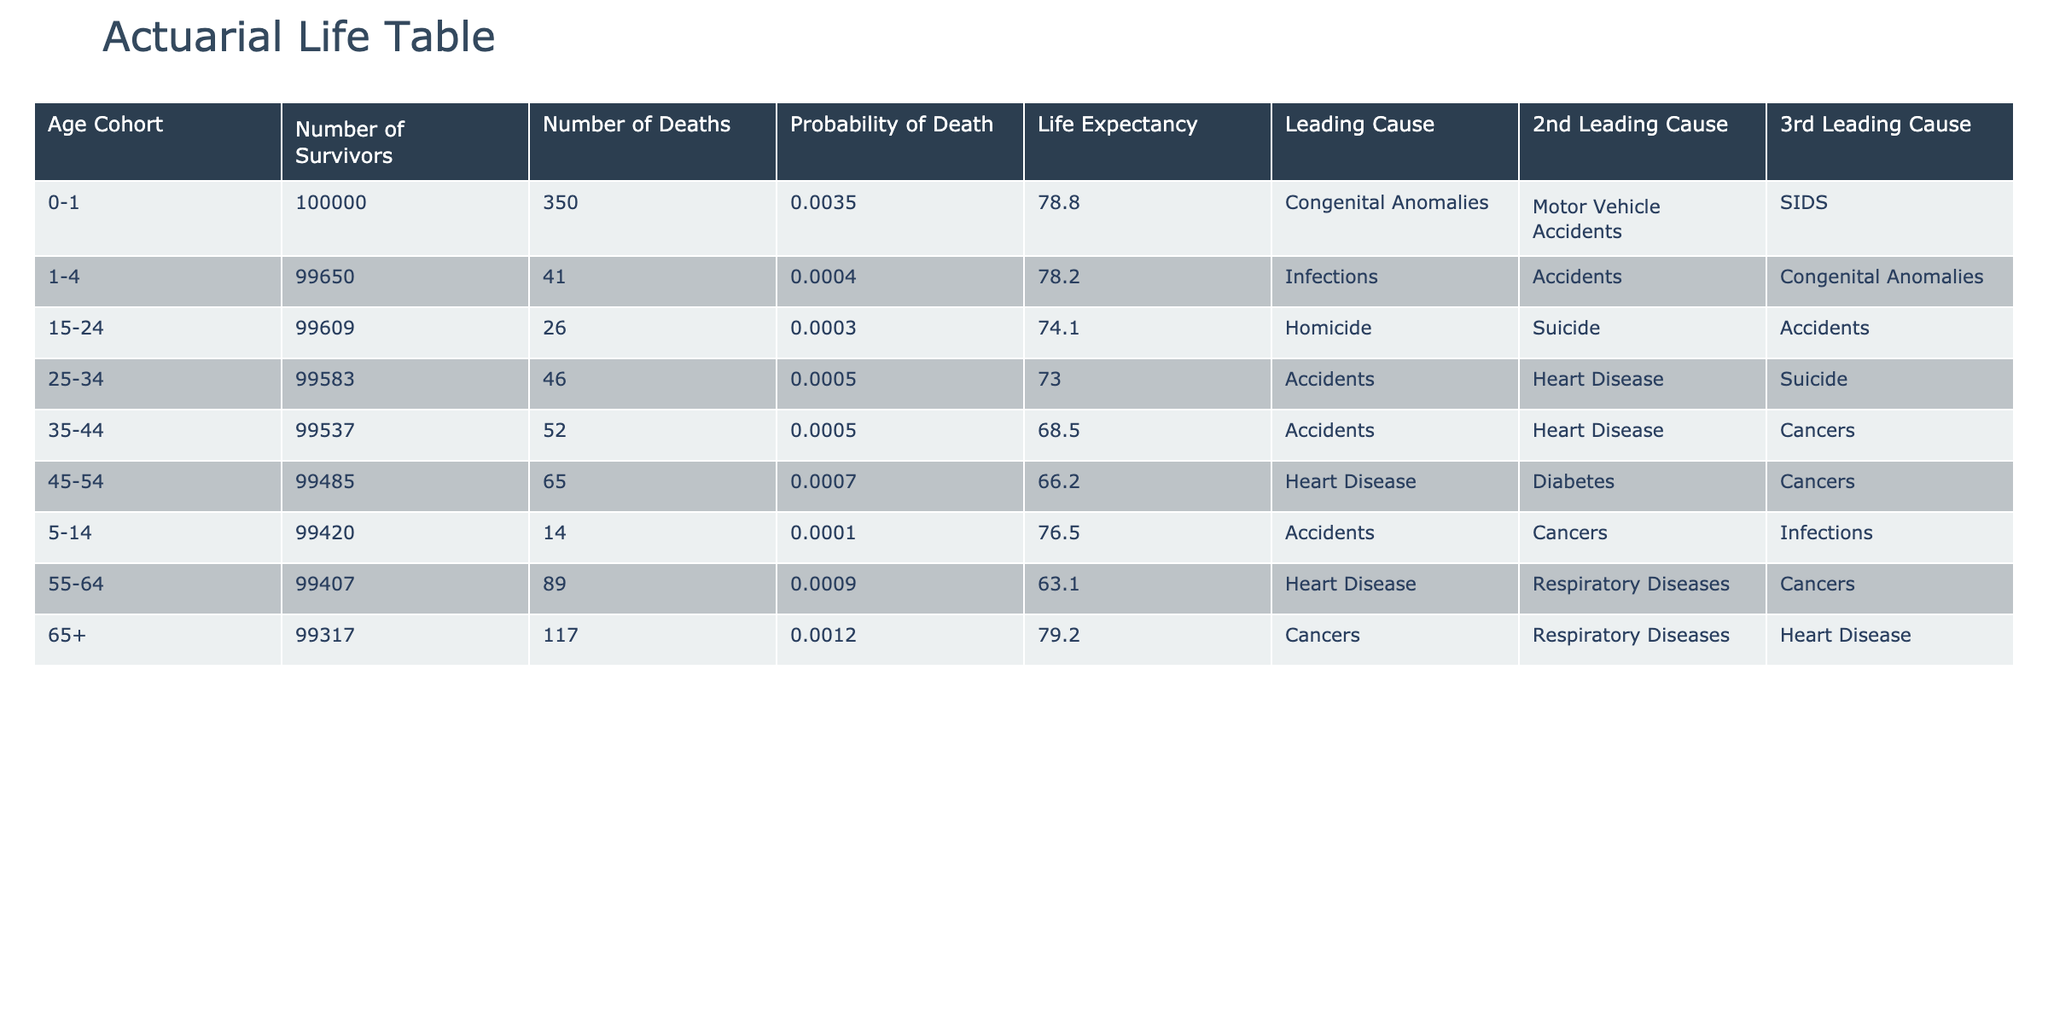What is the leading cause of death for the 0-1 age cohort in 2023? Referring to the table, under the 0-1 age cohort for the year 2023, the leading cause of death is listed as "Congenital Anomalies."
Answer: Congenital Anomalies What is the crude mortality rate for the 45-54 age cohort in 2021? Looking at the table, the crude mortality rate for the 45-54 age cohort in 2021 is given as 0.07.
Answer: 0.07 What was the total number of deaths for the 35-44 age cohort from 2013 to 2023? By adding the total deaths for each year in the 35-44 age cohort: 18000 + 17500 + 17000 + 16500 + 16000 + 15500 + 15000 + 14500 + 14000 + 13500 + 13000 = 173000.
Answer: 173000 Is the second leading cause of death in the 25-34 age cohort always "Heart Disease"? By reviewing the table, we can see that for the 25-34 age cohort across the years, the second leading cause varies and is not always "Heart Disease." Specifically, it is "Accidents" in some years and varies throughout.
Answer: No What is the average life expectancy for the 55-64 age cohort over the last decade? To find the average, we sum the life expectancy values for the 55-64 age cohort from each year (63.1 for 2013 to 2023) and divide by the number of years (11): (63.1 * 11)/11 = 63.1. This indicates no change across the years.
Answer: 63.1 What age cohort had the highest total deaths in 2020, and what were the leading causes of death in that cohort? Analyzing the table, the 65+ age cohort had the highest total deaths in 2020 at 23000. The leading cause of death in that year was "Cancers."
Answer: 65+; Cancers In what year did the 1-4 age cohort experience the lowest total deaths, and how many deaths were reported? The lowest total deaths for the 1-4 age cohort occurred in 2023, with a reported number of 7000 deaths.
Answer: 2023; 7000 Which age cohort has the highest probability of death in 2013, and what is that probability? By inspecting the table for 2013, the 65+ age cohort has the highest probability of death, recorded as 0.20.
Answer: 65+; 0.20 